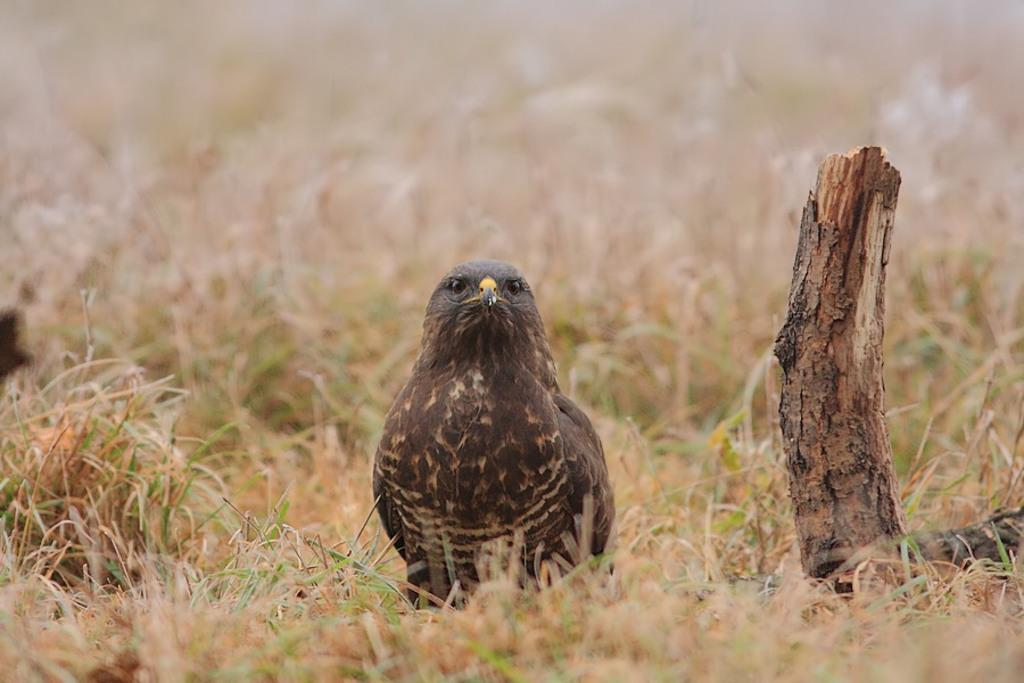What type of animal can be seen in the image? There is a bird in the image. What is the bird standing on? The bird is standing on grassland. What other object is present in the image? There is a wooden trunk in the image. What type of building can be seen in the background of the image? There is no building present in the image; it features a bird standing on grassland and a wooden trunk. What type of clover is growing near the bird in the image? There is no clover visible in the image; it only shows a bird standing on grassland and a wooden trunk. 